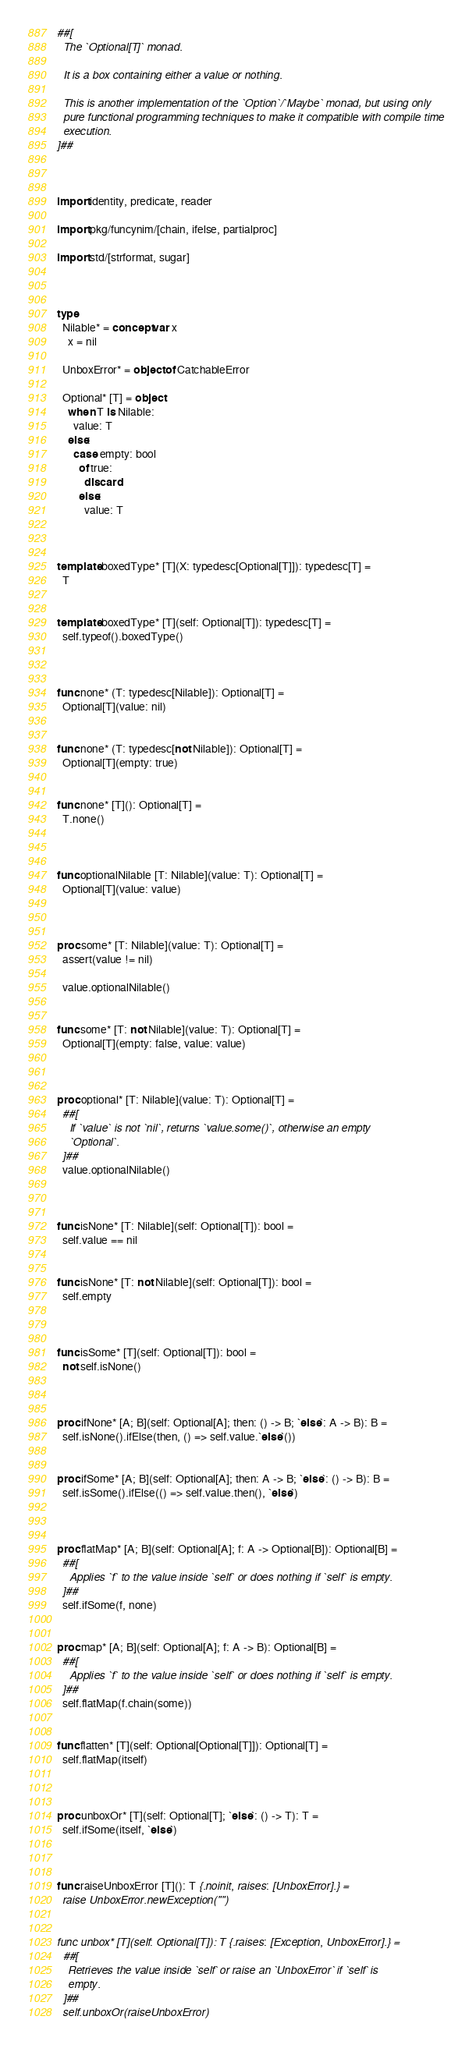Convert code to text. <code><loc_0><loc_0><loc_500><loc_500><_Nim_>##[
  The `Optional[T]` monad.

  It is a box containing either a value or nothing.

  This is another implementation of the `Option`/`Maybe` monad, but using only
  pure functional programming techniques to make it compatible with compile time
  execution.
]##



import identity, predicate, reader

import pkg/funcynim/[chain, ifelse, partialproc]

import std/[strformat, sugar]



type
  Nilable* = concept var x
    x = nil

  UnboxError* = object of CatchableError

  Optional* [T] = object
    when T is Nilable:
      value: T
    else:
      case empty: bool
        of true:
          discard
        else:
          value: T



template boxedType* [T](X: typedesc[Optional[T]]): typedesc[T] =
  T


template boxedType* [T](self: Optional[T]): typedesc[T] =
  self.typeof().boxedType()



func none* (T: typedesc[Nilable]): Optional[T] =
  Optional[T](value: nil)


func none* (T: typedesc[not Nilable]): Optional[T] =
  Optional[T](empty: true)


func none* [T](): Optional[T] =
  T.none()



func optionalNilable [T: Nilable](value: T): Optional[T] =
  Optional[T](value: value)



proc some* [T: Nilable](value: T): Optional[T] =
  assert(value != nil)

  value.optionalNilable()


func some* [T: not Nilable](value: T): Optional[T] =
  Optional[T](empty: false, value: value)



proc optional* [T: Nilable](value: T): Optional[T] =
  ##[
    If `value` is not `nil`, returns `value.some()`, otherwise an empty
    `Optional`.
  ]##
  value.optionalNilable()



func isNone* [T: Nilable](self: Optional[T]): bool =
  self.value == nil


func isNone* [T: not Nilable](self: Optional[T]): bool =
  self.empty



func isSome* [T](self: Optional[T]): bool =
  not self.isNone()



proc ifNone* [A; B](self: Optional[A]; then: () -> B; `else`: A -> B): B =
  self.isNone().ifElse(then, () => self.value.`else`())


proc ifSome* [A; B](self: Optional[A]; then: A -> B; `else`: () -> B): B =
  self.isSome().ifElse(() => self.value.then(), `else`)



proc flatMap* [A; B](self: Optional[A]; f: A -> Optional[B]): Optional[B] =
  ##[
    Applies `f` to the value inside `self` or does nothing if `self` is empty.
  ]##
  self.ifSome(f, none)


proc map* [A; B](self: Optional[A]; f: A -> B): Optional[B] =
  ##[
    Applies `f` to the value inside `self` or does nothing if `self` is empty.
  ]##
  self.flatMap(f.chain(some))


func flatten* [T](self: Optional[Optional[T]]): Optional[T] =
  self.flatMap(itself)



proc unboxOr* [T](self: Optional[T]; `else`: () -> T): T =
  self.ifSome(itself, `else`)



func raiseUnboxError [T](): T {.noinit, raises: [UnboxError].} =
  raise UnboxError.newException("")


func unbox* [T](self: Optional[T]): T {.raises: [Exception, UnboxError].} =
  ##[
    Retrieves the value inside `self` or raise an `UnboxError` if `self` is
    empty.
  ]##
  self.unboxOr(raiseUnboxError)


</code> 